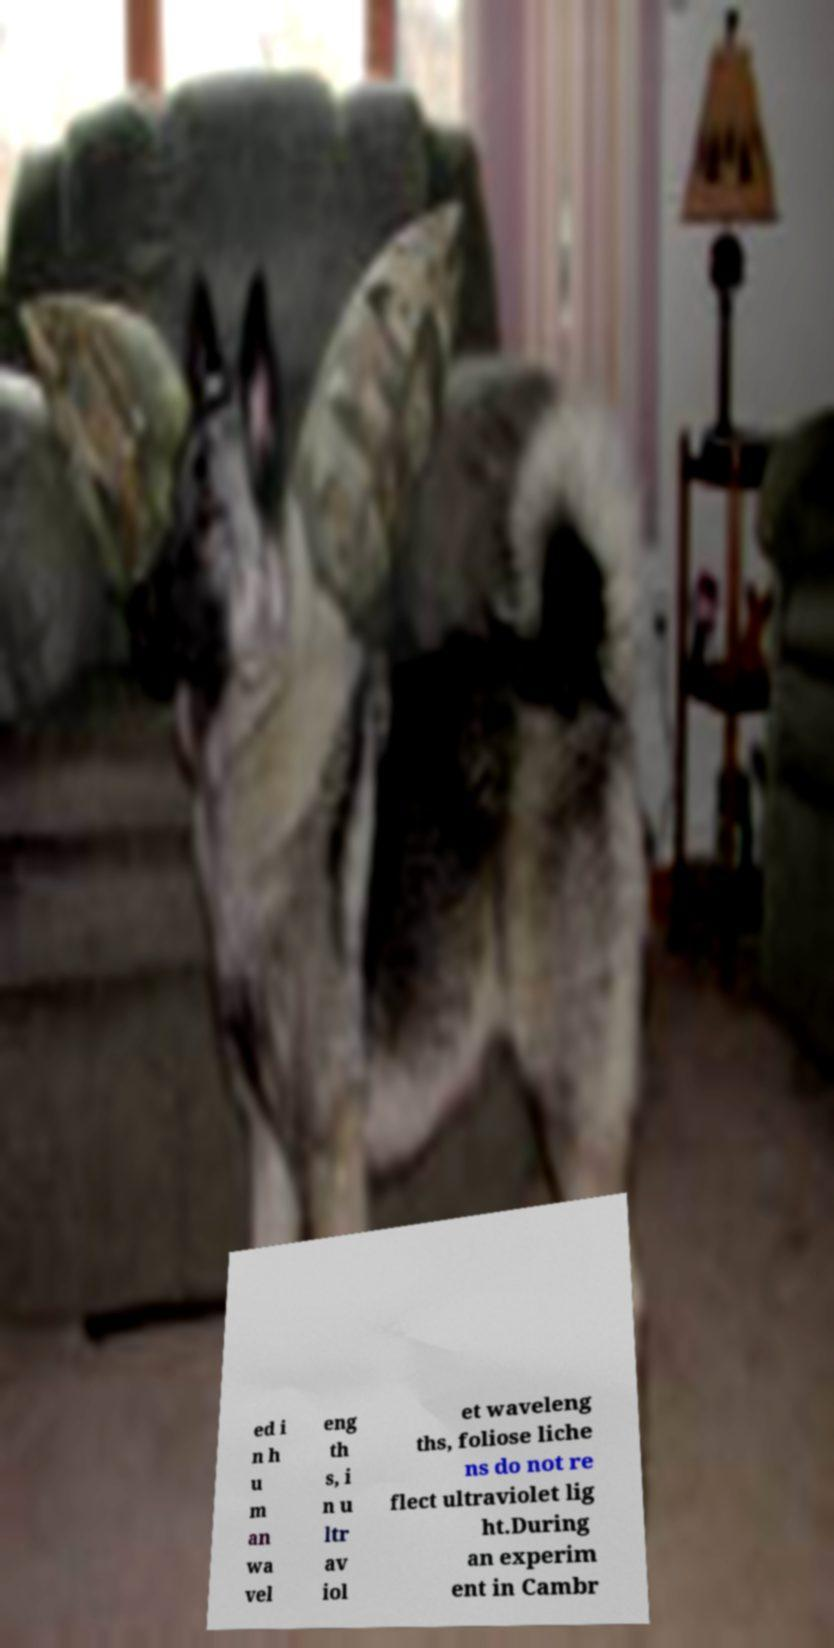For documentation purposes, I need the text within this image transcribed. Could you provide that? ed i n h u m an wa vel eng th s, i n u ltr av iol et waveleng ths, foliose liche ns do not re flect ultraviolet lig ht.During an experim ent in Cambr 